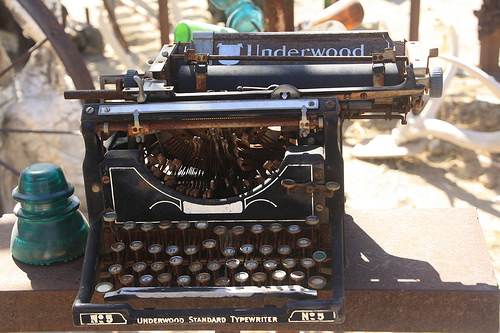<image>
Is there a keys on the desk? Yes. Looking at the image, I can see the keys is positioned on top of the desk, with the desk providing support. 